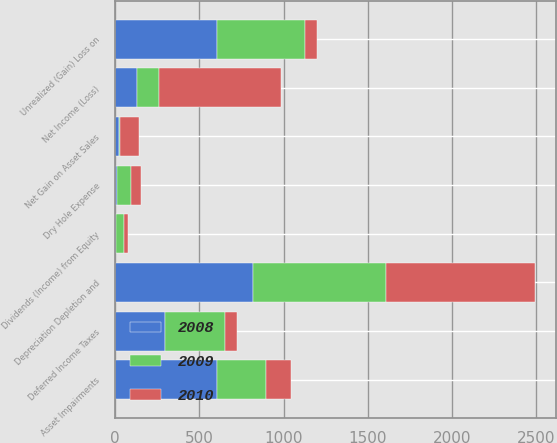<chart> <loc_0><loc_0><loc_500><loc_500><stacked_bar_chart><ecel><fcel>Net Income (Loss)<fcel>Depreciation Depletion and<fcel>Dry Hole Expense<fcel>Net Gain on Asset Sales<fcel>Asset Impairments<fcel>Deferred Income Taxes<fcel>Dividends (Income) from Equity<fcel>Unrealized (Gain) Loss on<nl><fcel>2010<fcel>725<fcel>883<fcel>58<fcel>113<fcel>144<fcel>71<fcel>21<fcel>70<nl><fcel>2008<fcel>131<fcel>816<fcel>11<fcel>22<fcel>604<fcel>296<fcel>8<fcel>606<nl><fcel>2009<fcel>131<fcel>791<fcel>84<fcel>5<fcel>294<fcel>359<fcel>47<fcel>522<nl></chart> 